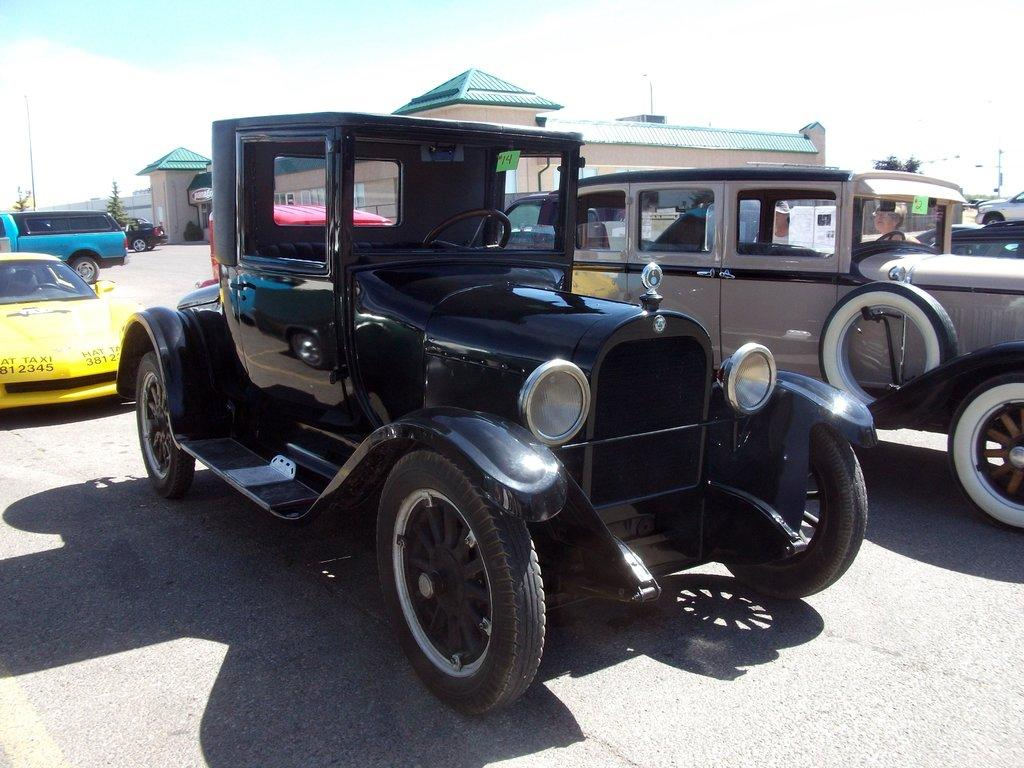What is the main subject in the foreground of the image? There is a vehicle in the foreground of the image. What else can be seen in the background of the image? There are vehicles, houses, plants, and the sky visible in the background of the image. How many vehicles are present in the image? There are at least two vehicles in the image, one in the foreground and others in the background. What type of natural elements are present in the image? Plants are present in the background of the image. What type of caption is written on the side of the vehicle in the image? There is no caption visible on the side of the vehicle in the image. What type of cork can be seen in the image? There is no cork present in the image. 